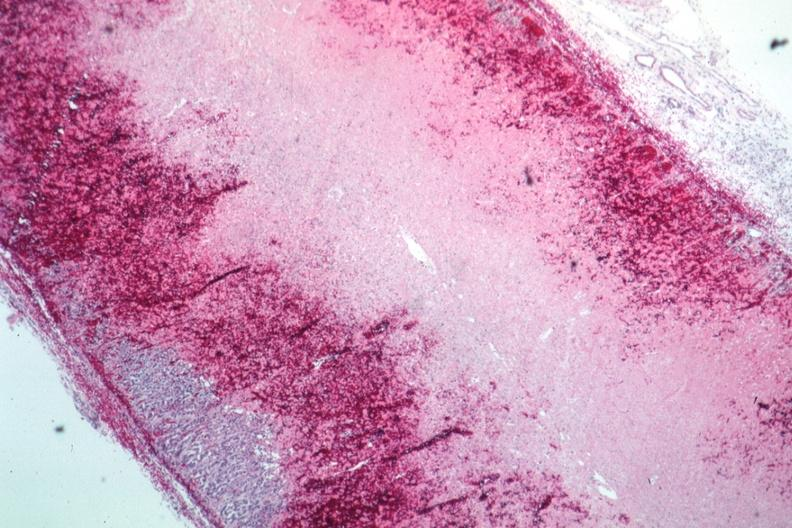where is this part in the figure?
Answer the question using a single word or phrase. Endocrine system 